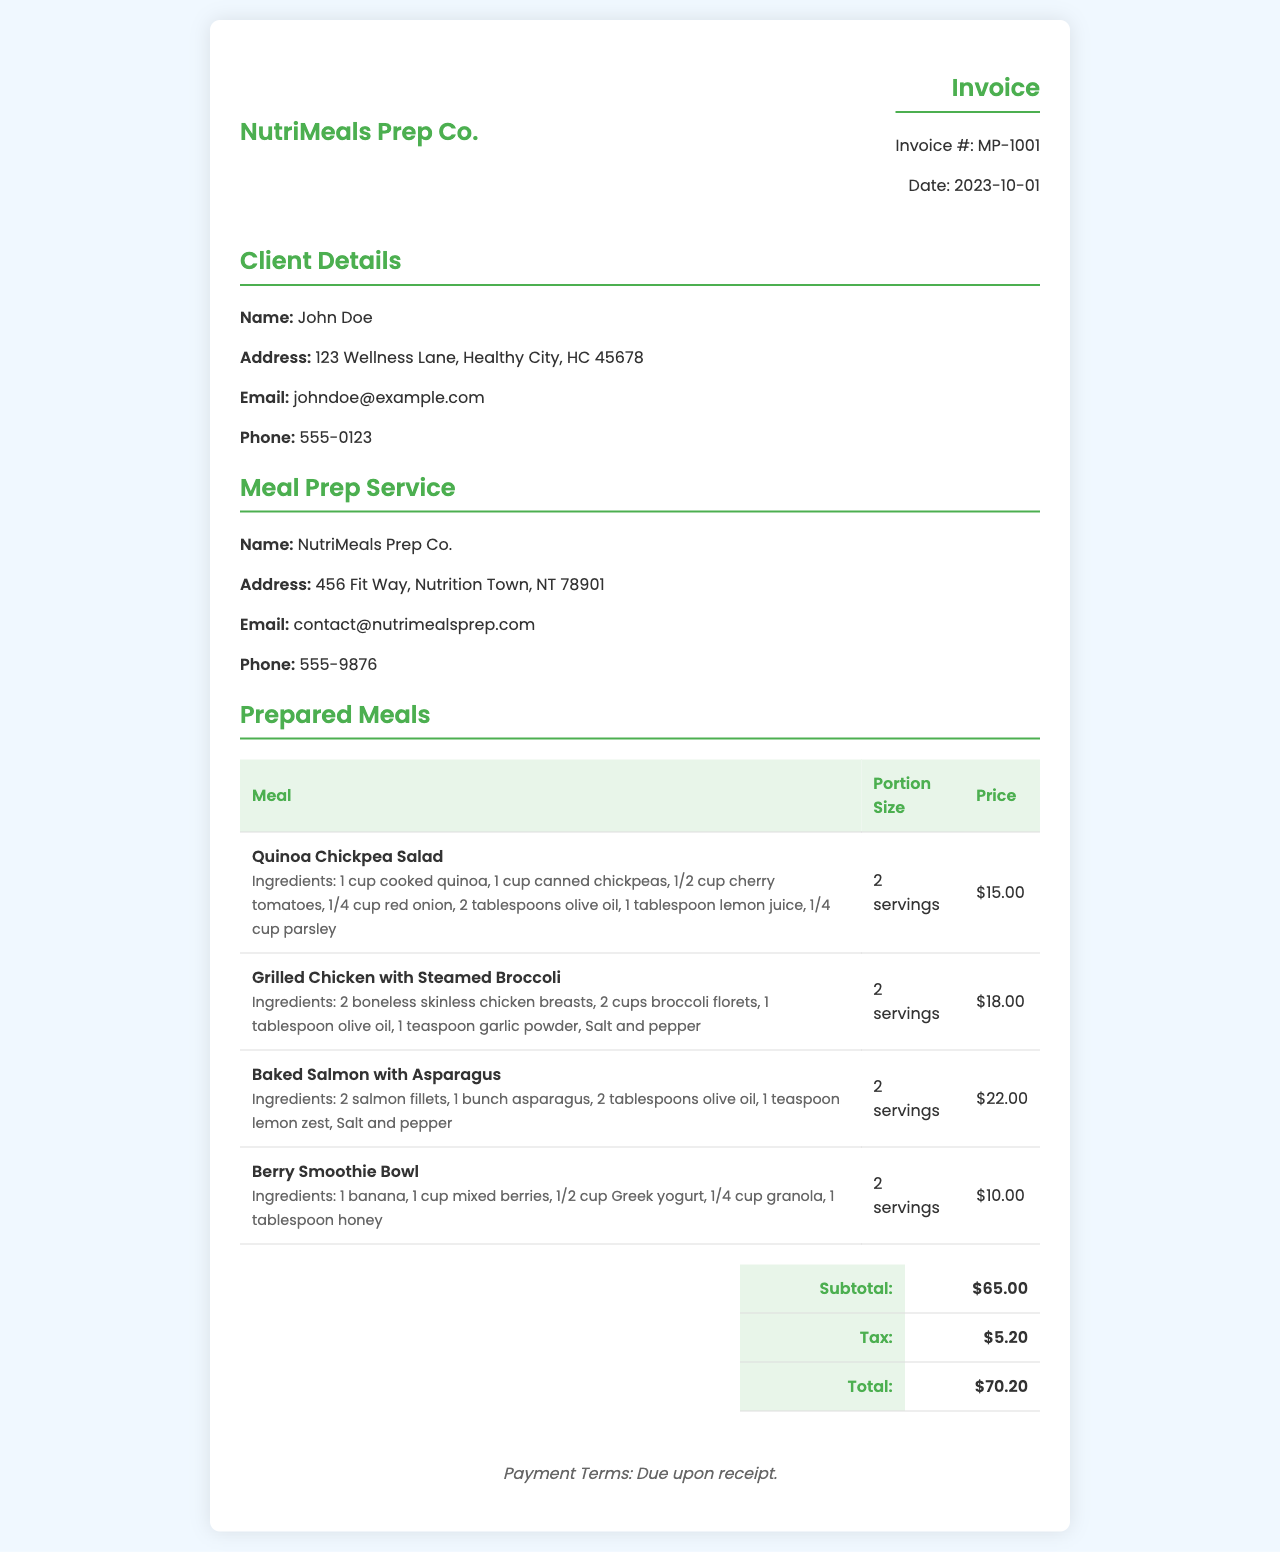What is the invoice number? The invoice number can be found in the header of the document, labeled as "Invoice #".
Answer: MP-1001 What is the date of the invoice? The date of the invoice is included in the header section, clearly marked as the date issued.
Answer: 2023-10-01 Who is the client? The client's name is listed under the client details section of the invoice.
Answer: John Doe What is the subtotal amount? The subtotal is calculated before tax and can be found in the summary table.
Answer: $65.00 How many servings are provided for the Grilled Chicken with Steamed Broccoli? The portion size for this meal is specified in the table with the meal details.
Answer: 2 servings Which meal is the most expensive? The meal prices can be compared in the table; the one with the highest price is noted as the most expensive.
Answer: Baked Salmon with Asparagus What is the total cost after tax? The total cost is the final amount calculated in the summary table including tax.
Answer: $70.20 What ingredients are used in the Berry Smoothie Bowl? The ingredients for each meal are listed directly under the meal description.
Answer: 1 banana, 1 cup mixed berries, 1/2 cup Greek yogurt, 1/4 cup granola, 1 tablespoon honey What are the payment terms? The payment terms are mentioned at the bottom of the invoice, providing information on when payment is due.
Answer: Due upon receipt 